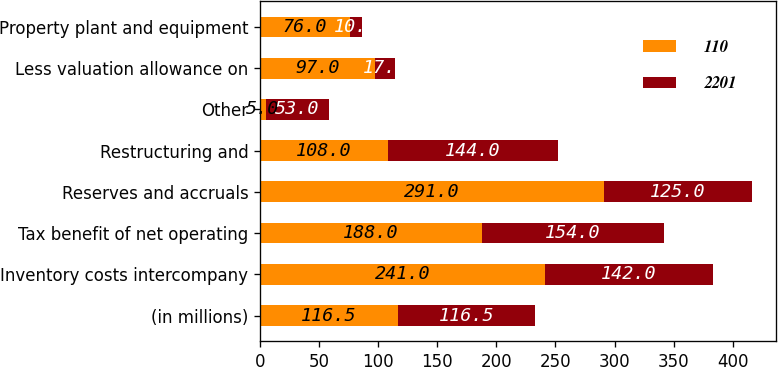Convert chart. <chart><loc_0><loc_0><loc_500><loc_500><stacked_bar_chart><ecel><fcel>(in millions)<fcel>Inventory costs intercompany<fcel>Tax benefit of net operating<fcel>Reserves and accruals<fcel>Restructuring and<fcel>Other<fcel>Less valuation allowance on<fcel>Property plant and equipment<nl><fcel>110<fcel>116.5<fcel>241<fcel>188<fcel>291<fcel>108<fcel>5<fcel>97<fcel>76<nl><fcel>2201<fcel>116.5<fcel>142<fcel>154<fcel>125<fcel>144<fcel>53<fcel>17<fcel>10<nl></chart> 